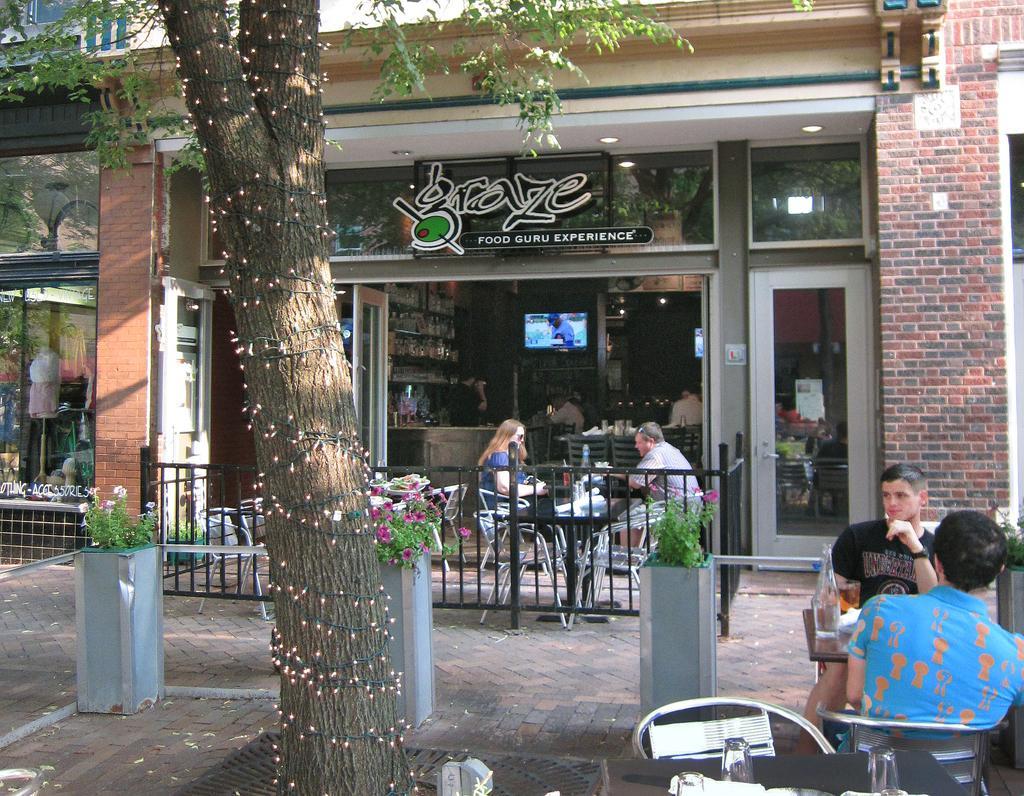Please provide a concise description of this image. These persons are sitting on the chairs. We can see bottles,glass on the table. On the background we can see wall,glass door,chairs,television. We can see tree. 